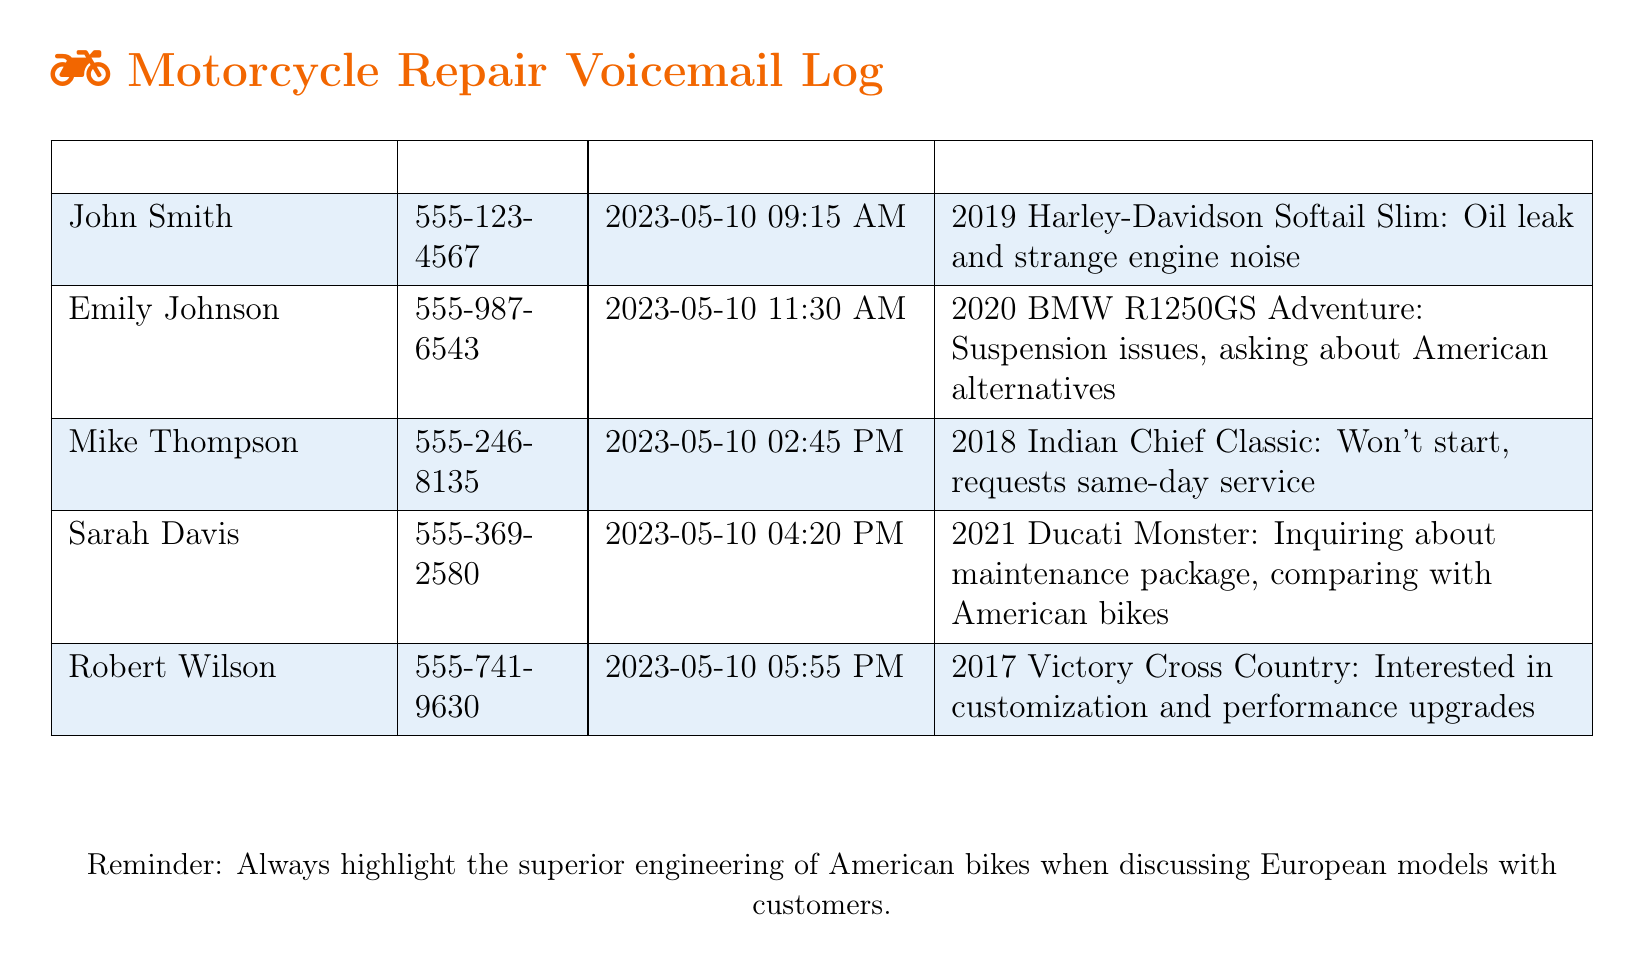What is the repair issue for John Smith? John Smith's voicemail mentions an oil leak and strange engine noise for his 2019 Harley-Davidson Softail Slim.
Answer: Oil leak and strange engine noise What time did Robert Wilson call? Robert Wilson's call was logged at 5:55 PM on May 10, 2023.
Answer: 5:55 PM Which motorcycle brand does Emily Johnson inquire about? Emily Johnson inquires about the BMW, comparing it with American alternatives.
Answer: BMW What specific motorcycle model is associated with Mike Thompson's issue? Mike Thompson's issue is related to the 2018 Indian Chief Classic that won't start.
Answer: 2018 Indian Chief Classic How many customers requested same-day service? Only Mike Thompson requested same-day service in his voicemail.
Answer: One Which motorcycle did Sarah Davis inquire about? Sarah Davis inquired about the 2021 Ducati Monster and compared it with American bikes.
Answer: 2021 Ducati Monster What is stated as a reminder in the document? The document reminds to highlight the superior engineering of American bikes when discussing European models.
Answer: Highlight the superior engineering of American bikes What customization interests does Robert Wilson have? Robert Wilson is interested in customization and performance upgrades for his 2017 Victory Cross Country.
Answer: Customization and performance upgrades What type of service does Emily Johnson ask about? Emily Johnson is asking about suspension issues, particularly in relation to American alternatives.
Answer: Suspension issues, American alternatives 